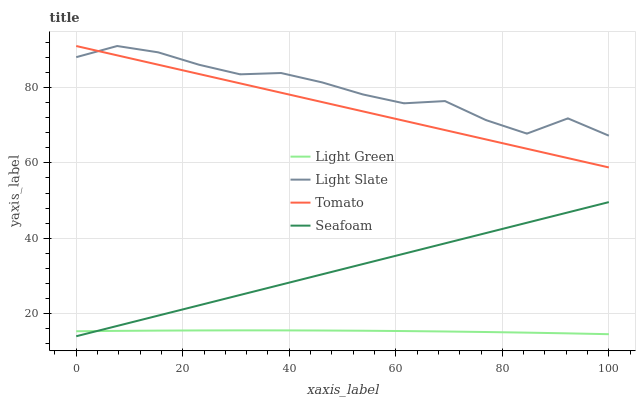Does Light Green have the minimum area under the curve?
Answer yes or no. Yes. Does Light Slate have the maximum area under the curve?
Answer yes or no. Yes. Does Tomato have the minimum area under the curve?
Answer yes or no. No. Does Tomato have the maximum area under the curve?
Answer yes or no. No. Is Seafoam the smoothest?
Answer yes or no. Yes. Is Light Slate the roughest?
Answer yes or no. Yes. Is Tomato the smoothest?
Answer yes or no. No. Is Tomato the roughest?
Answer yes or no. No. Does Seafoam have the lowest value?
Answer yes or no. Yes. Does Tomato have the lowest value?
Answer yes or no. No. Does Tomato have the highest value?
Answer yes or no. Yes. Does Seafoam have the highest value?
Answer yes or no. No. Is Light Green less than Tomato?
Answer yes or no. Yes. Is Light Slate greater than Light Green?
Answer yes or no. Yes. Does Light Slate intersect Tomato?
Answer yes or no. Yes. Is Light Slate less than Tomato?
Answer yes or no. No. Is Light Slate greater than Tomato?
Answer yes or no. No. Does Light Green intersect Tomato?
Answer yes or no. No. 